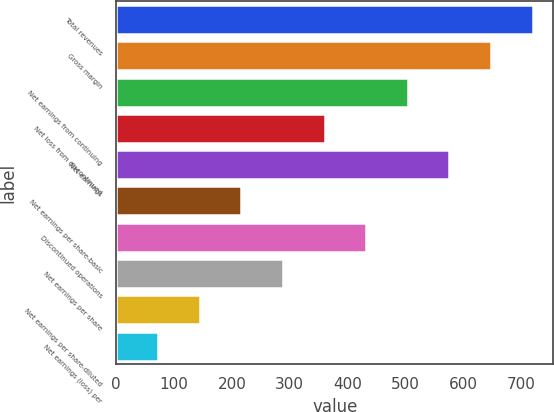<chart> <loc_0><loc_0><loc_500><loc_500><bar_chart><fcel>Total revenues<fcel>Gross margin<fcel>Net earnings from continuing<fcel>Net loss from discontinued<fcel>Net earnings<fcel>Net earnings per share-basic<fcel>Discontinued operations<fcel>Net earnings per share<fcel>Net earnings per share-diluted<fcel>Net earnings (loss) per<nl><fcel>720.3<fcel>648.32<fcel>504.44<fcel>360.56<fcel>576.38<fcel>216.68<fcel>432.5<fcel>288.62<fcel>144.74<fcel>72.8<nl></chart> 